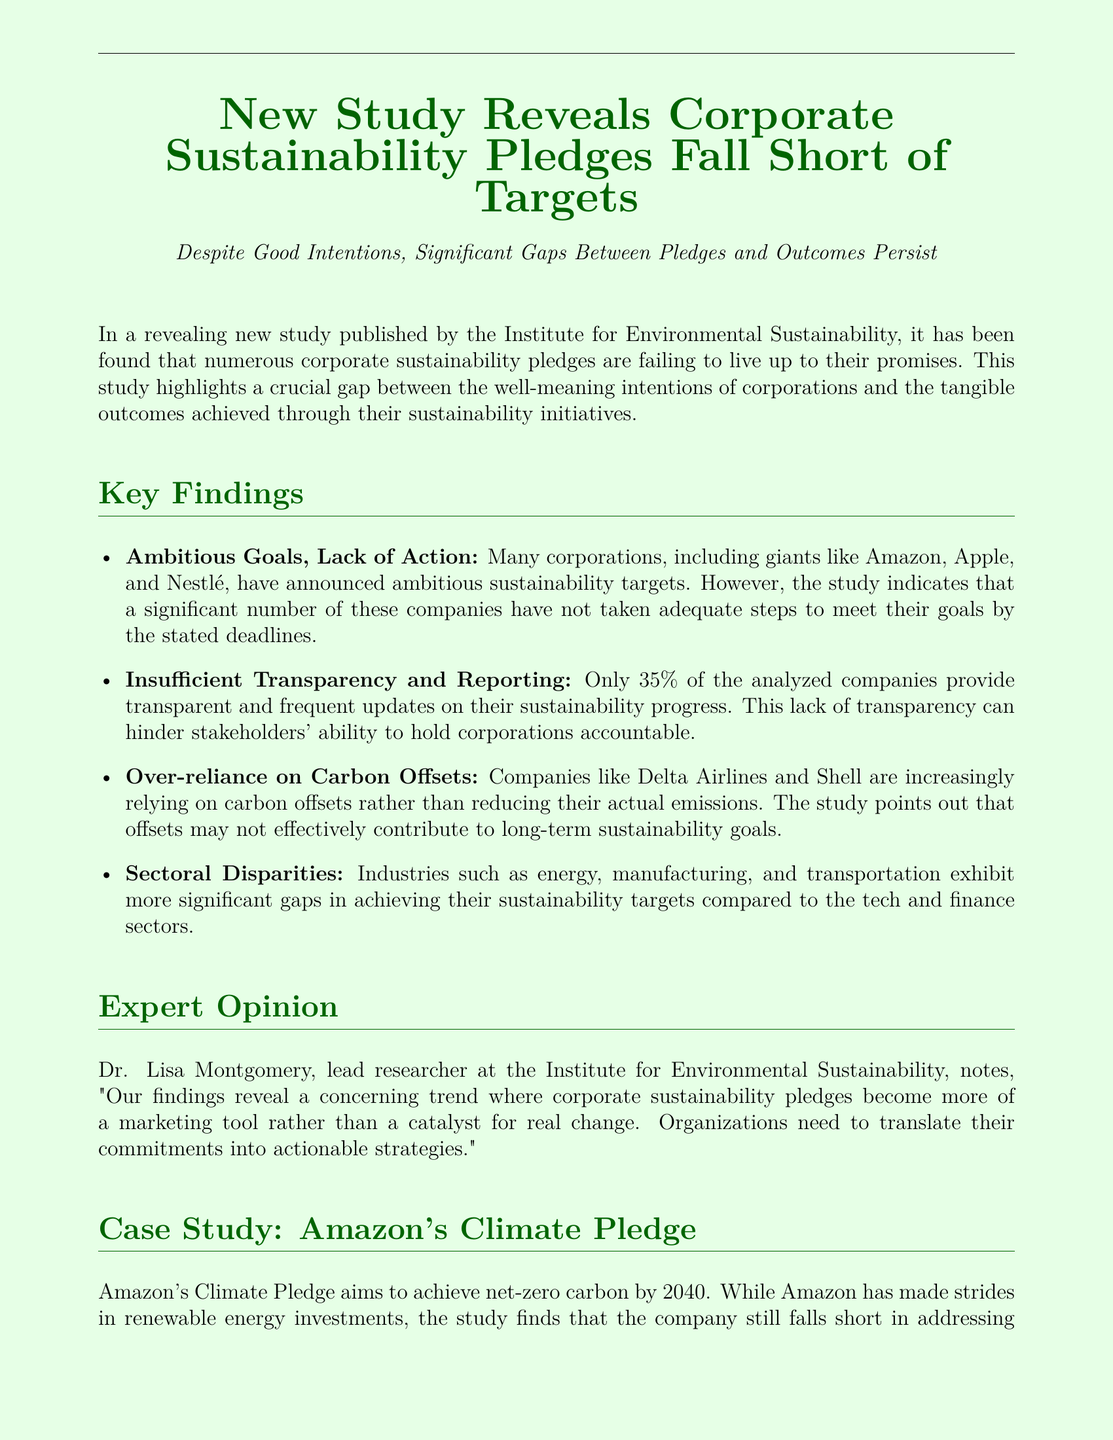What organization's study reveals gaps in corporate sustainability? The organization that published the study is the Institute for Environmental Sustainability.
Answer: Institute for Environmental Sustainability What percentage of companies provides transparent sustainability updates? The document states that only 35% of the analyzed companies provide transparent updates.
Answer: 35% Which company aims to achieve net-zero carbon by 2040? According to the case study, Amazon's Climate Pledge aims for net-zero carbon by 2040.
Answer: Amazon What is the primary issue highlighted by Dr. Lisa Montgomery regarding sustainability pledges? Dr. Lisa Montgomery notes that corporate sustainability pledges often become marketing tools rather than catalysts for real change.
Answer: Marketing tool Which industries show more substantial gaps in sustainability targets? The document mentions that the energy, manufacturing, and transportation sectors exhibit significant gaps compared to tech and finance.
Answer: Energy, manufacturing, and transportation What is indicated as a potential issue with companies relying on carbon offsets? The study suggests that carbon offsets may not effectively contribute to long-term sustainability goals.
Answer: Long-term sustainability goals What example is used to illustrate challenges in large-scale sustainability efforts? Amazon's Climate Pledge is used as a case study to illustrate these complexities and challenges.
Answer: Amazon's Climate Pledge 